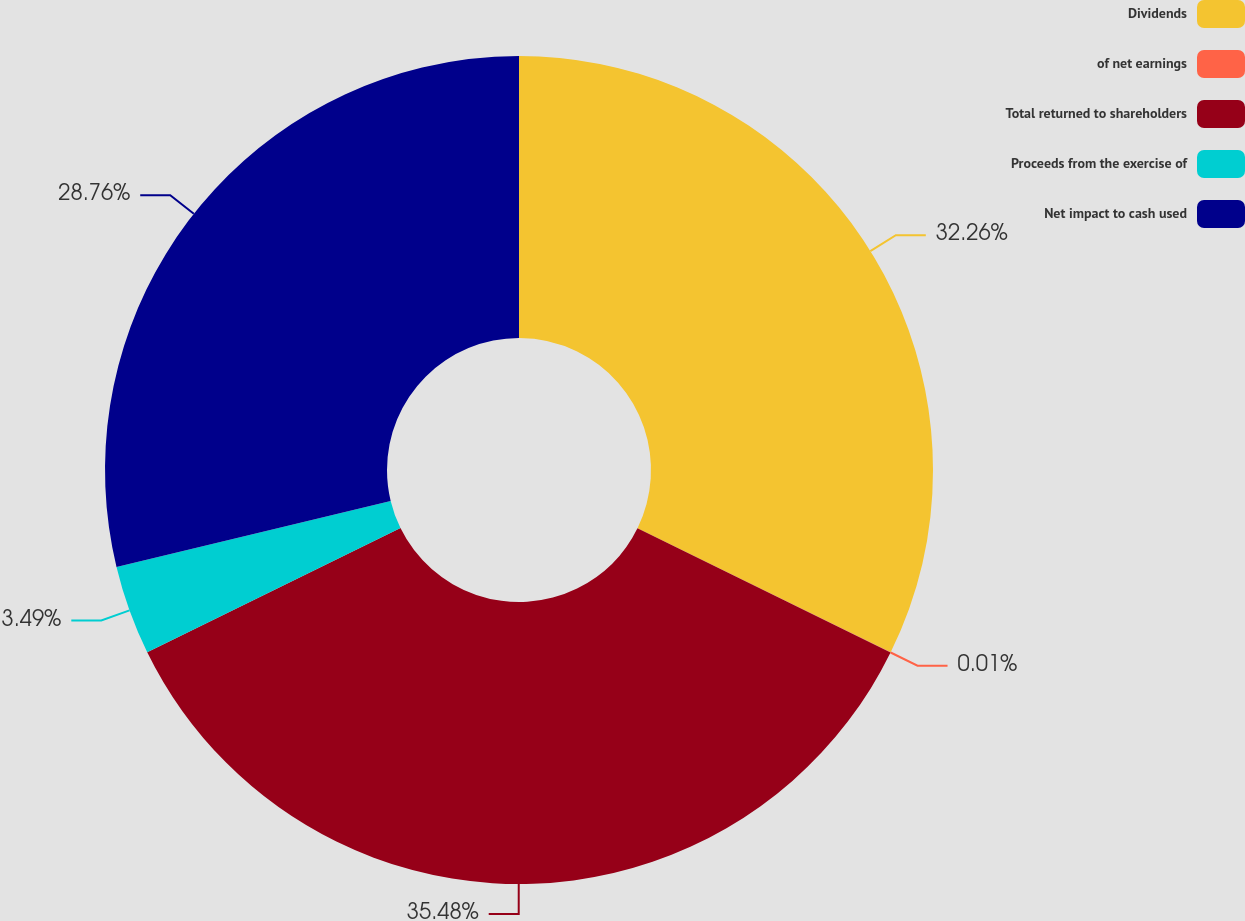Convert chart. <chart><loc_0><loc_0><loc_500><loc_500><pie_chart><fcel>Dividends<fcel>of net earnings<fcel>Total returned to shareholders<fcel>Proceeds from the exercise of<fcel>Net impact to cash used<nl><fcel>32.26%<fcel>0.01%<fcel>35.48%<fcel>3.49%<fcel>28.76%<nl></chart> 